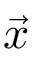Convert formula to latex. <formula><loc_0><loc_0><loc_500><loc_500>\vec { x }</formula> 